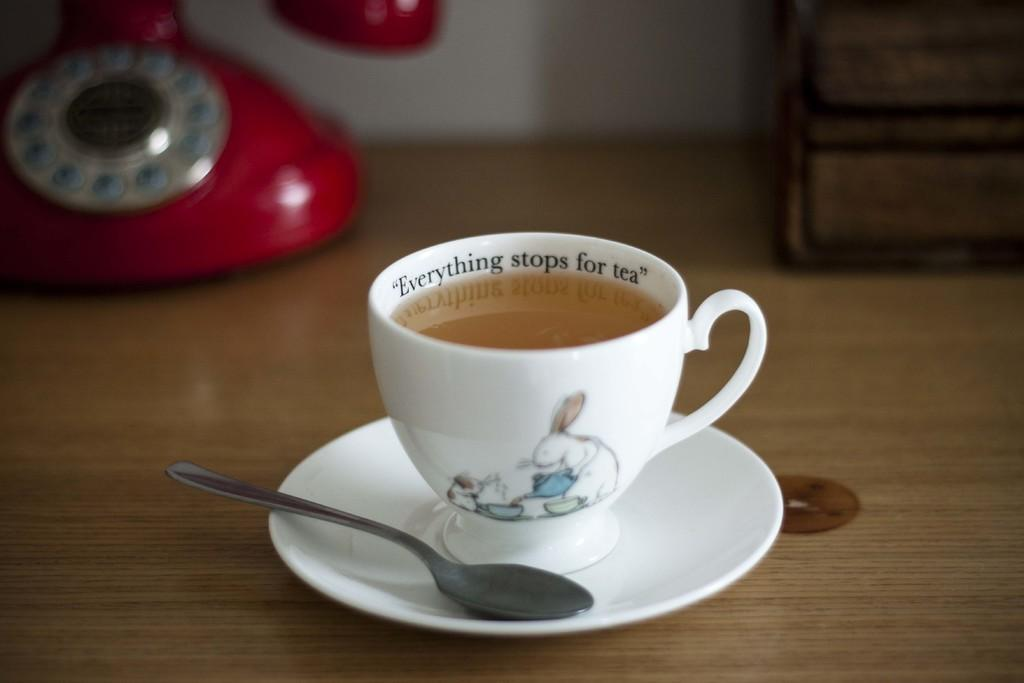What object in the image is typically used for communication? There is a telephone in the image, which is typically used for communication. What beverage is in the cup in the image? There is coffee in the cup in the image. What is the saucer used for in the image? The saucer is used to hold the cup in the image. What utensil is present in the image? There is a spoon in the image. What type of flame can be seen in the image? There is no flame present in the image. 